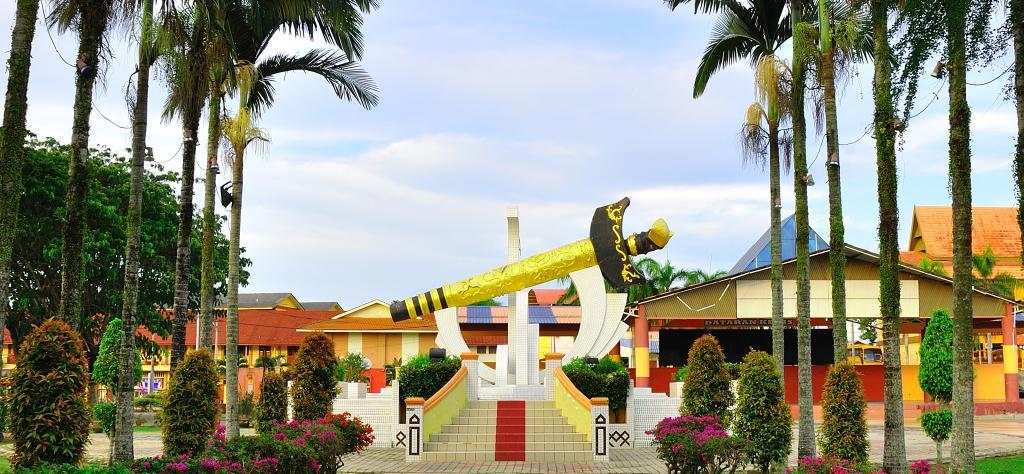What type of natural elements can be seen in the image? There are flowers and trees in the image. What type of man-made structures are present in the image? There are buildings in the image. What can be seen in the background of the image? There are clouds visible in the background of the image. What is the main subject in the middle of the image? There is a sculpture in the middle of the image. Can you tell me how many ladybugs are crawling on the sculpture in the image? There are no ladybugs present on the sculpture or in the image. Is there a carpenter working on the buildings in the image? There is no indication of a carpenter or any construction work happening in the image. 